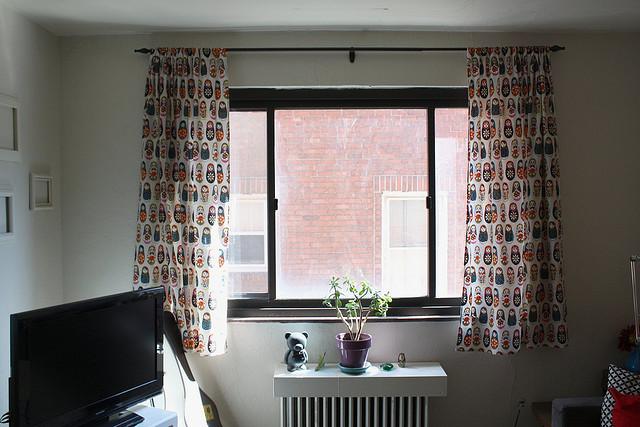What color are the curtains?
Be succinct. White, black, and red. Do you like these curtains?
Quick response, please. Yes. Why is this vase near the window?
Keep it brief. Sunlight. Is there a T.V.?
Quick response, please. Yes. Where is the plant?
Concise answer only. On radiator or shelf of some kind. 